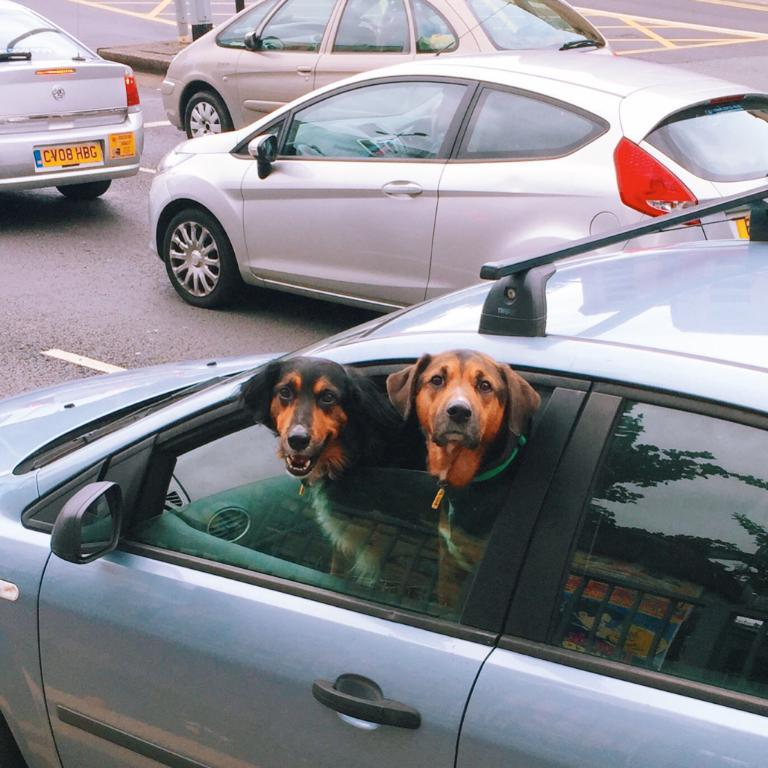What is the main subject of the image? The main subject of the image is a car on the road. What is inside the car? There are dogs inside the car. What can be seen in the background of the image? Other cars are visible on the road in front of the car. What type of drug is the writer using in the image? There is no writer or drug present in the image; it features a car with dogs inside and other cars on the road. 